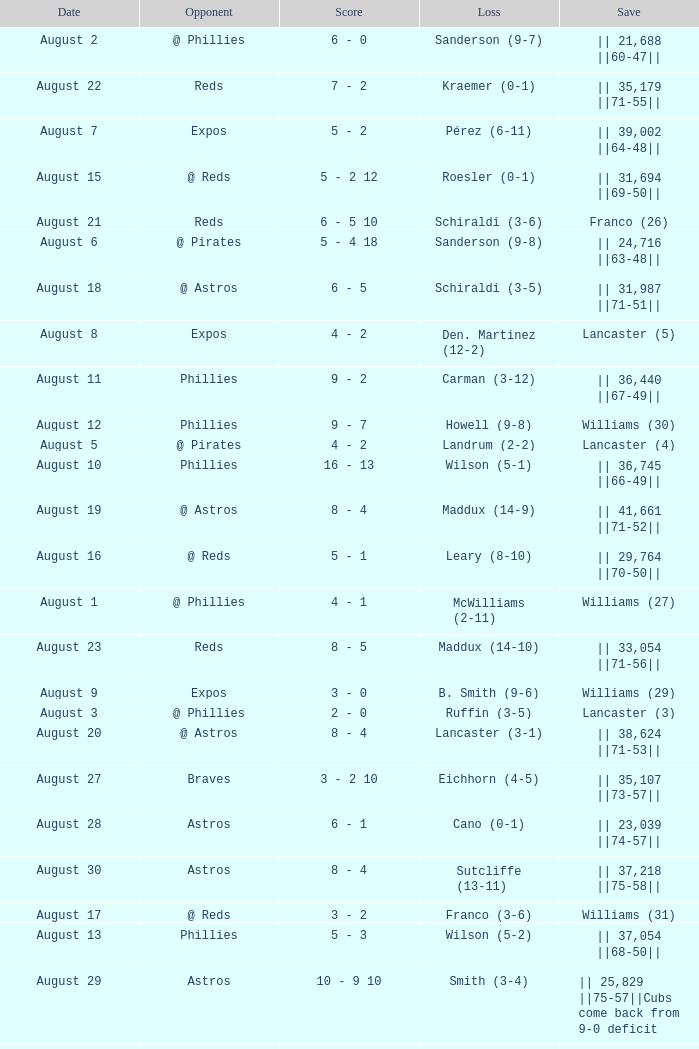Name the opponent with loss of sanderson (9-8) @ Pirates. 